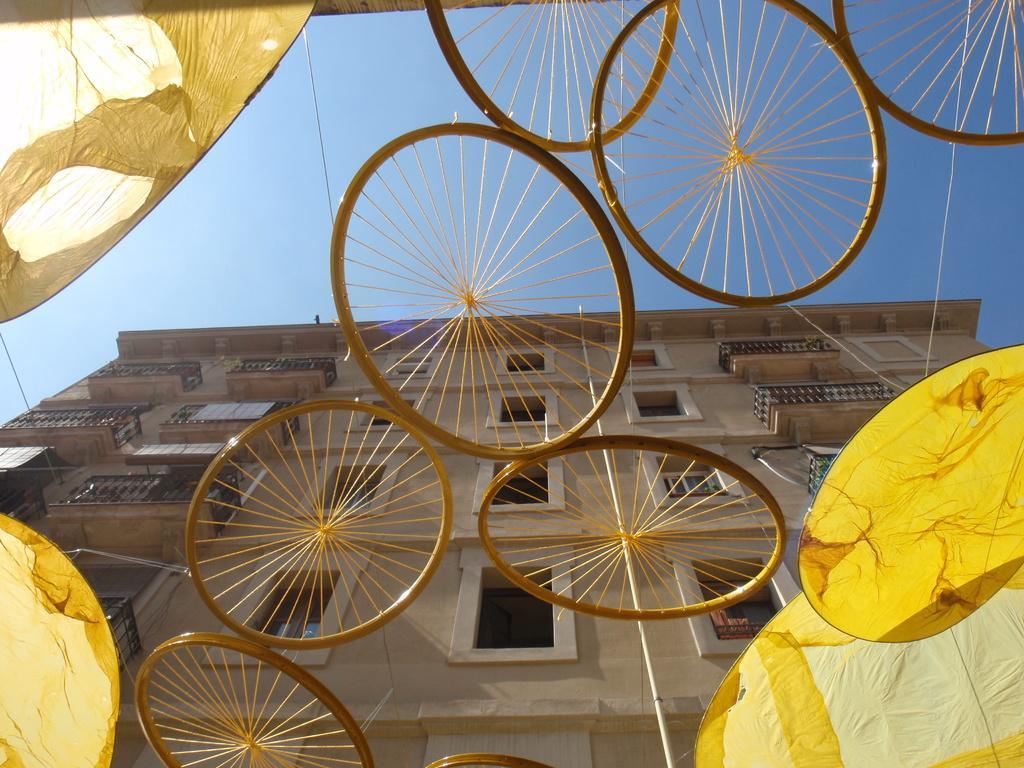Could you give a brief overview of what you see in this image? In this image there is the sky truncated towards the top of the image, there is a building truncated towards the bottom of the image, there are objects truncated towards the right of the image, there are objects truncated towards the bottom of the image, there are objects truncated towards the left of the image, there are objects truncated towards the top of the image, there is a wire truncated towards the left of the image. 